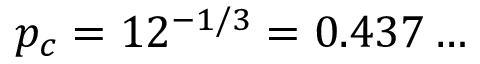<formula> <loc_0><loc_0><loc_500><loc_500>p _ { c } = 1 2 ^ { - 1 / 3 } = 0 . 4 3 7 \dots</formula> 